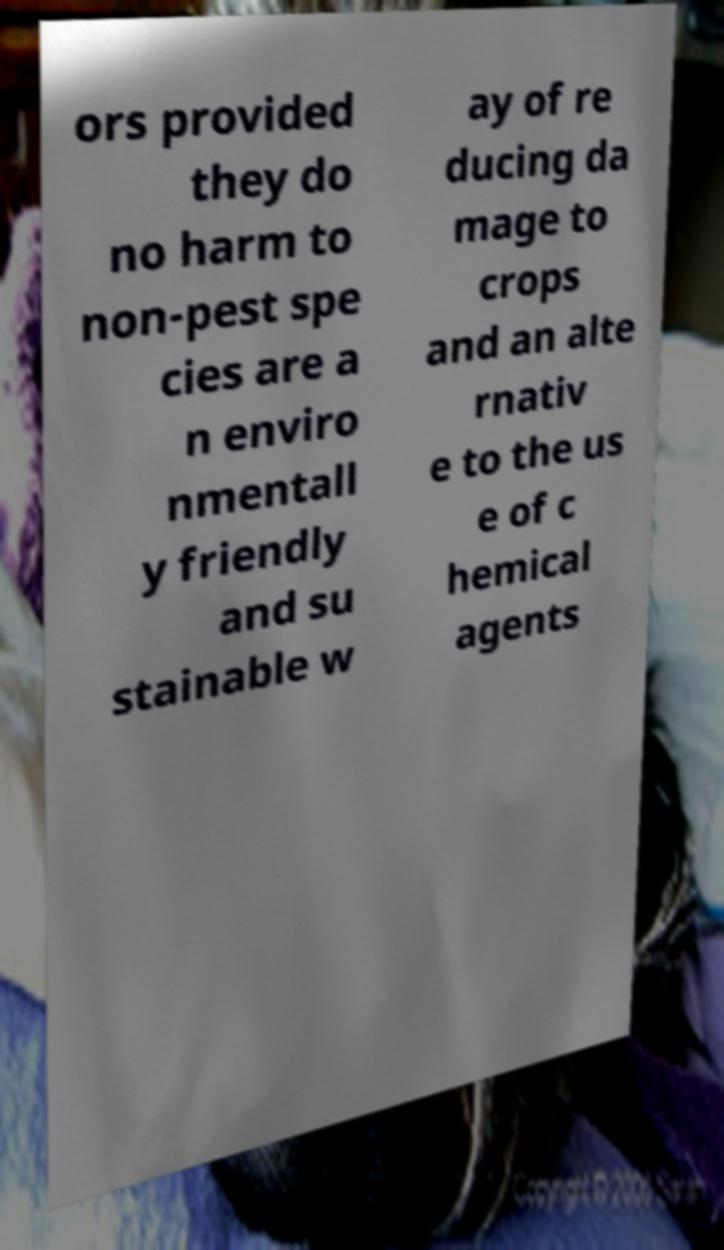What messages or text are displayed in this image? I need them in a readable, typed format. ors provided they do no harm to non-pest spe cies are a n enviro nmentall y friendly and su stainable w ay of re ducing da mage to crops and an alte rnativ e to the us e of c hemical agents 